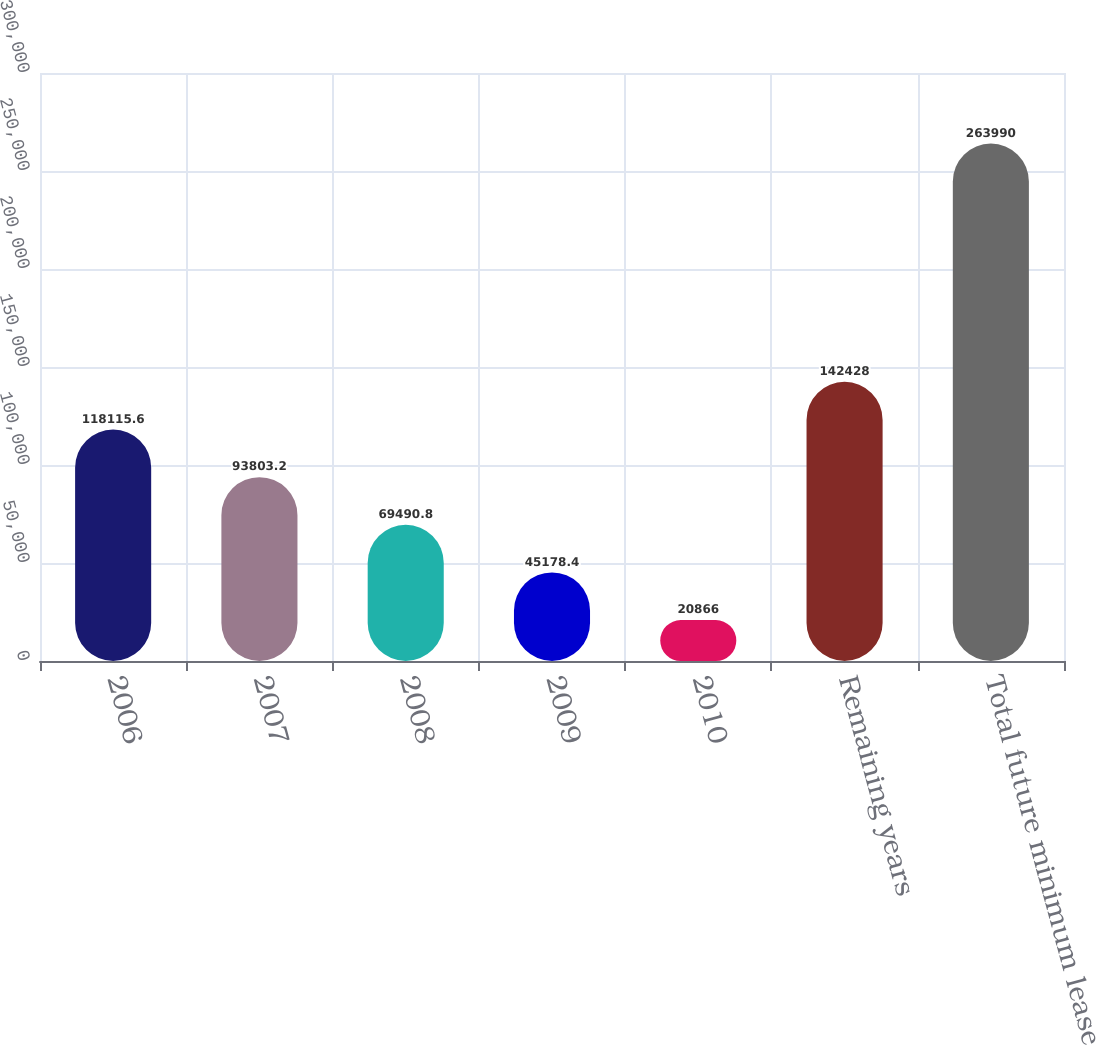Convert chart. <chart><loc_0><loc_0><loc_500><loc_500><bar_chart><fcel>2006<fcel>2007<fcel>2008<fcel>2009<fcel>2010<fcel>Remaining years<fcel>Total future minimum lease<nl><fcel>118116<fcel>93803.2<fcel>69490.8<fcel>45178.4<fcel>20866<fcel>142428<fcel>263990<nl></chart> 